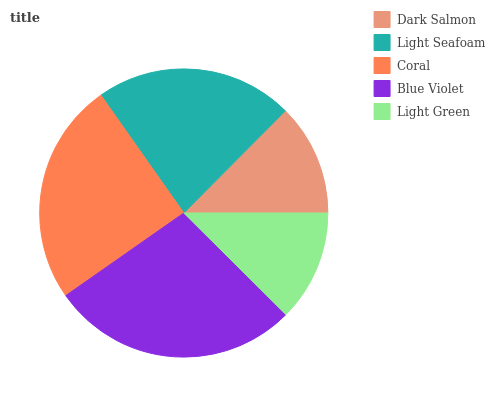Is Light Green the minimum?
Answer yes or no. Yes. Is Blue Violet the maximum?
Answer yes or no. Yes. Is Light Seafoam the minimum?
Answer yes or no. No. Is Light Seafoam the maximum?
Answer yes or no. No. Is Light Seafoam greater than Dark Salmon?
Answer yes or no. Yes. Is Dark Salmon less than Light Seafoam?
Answer yes or no. Yes. Is Dark Salmon greater than Light Seafoam?
Answer yes or no. No. Is Light Seafoam less than Dark Salmon?
Answer yes or no. No. Is Light Seafoam the high median?
Answer yes or no. Yes. Is Light Seafoam the low median?
Answer yes or no. Yes. Is Blue Violet the high median?
Answer yes or no. No. Is Light Green the low median?
Answer yes or no. No. 